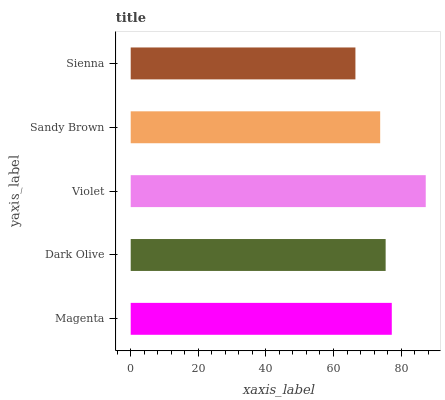Is Sienna the minimum?
Answer yes or no. Yes. Is Violet the maximum?
Answer yes or no. Yes. Is Dark Olive the minimum?
Answer yes or no. No. Is Dark Olive the maximum?
Answer yes or no. No. Is Magenta greater than Dark Olive?
Answer yes or no. Yes. Is Dark Olive less than Magenta?
Answer yes or no. Yes. Is Dark Olive greater than Magenta?
Answer yes or no. No. Is Magenta less than Dark Olive?
Answer yes or no. No. Is Dark Olive the high median?
Answer yes or no. Yes. Is Dark Olive the low median?
Answer yes or no. Yes. Is Magenta the high median?
Answer yes or no. No. Is Violet the low median?
Answer yes or no. No. 